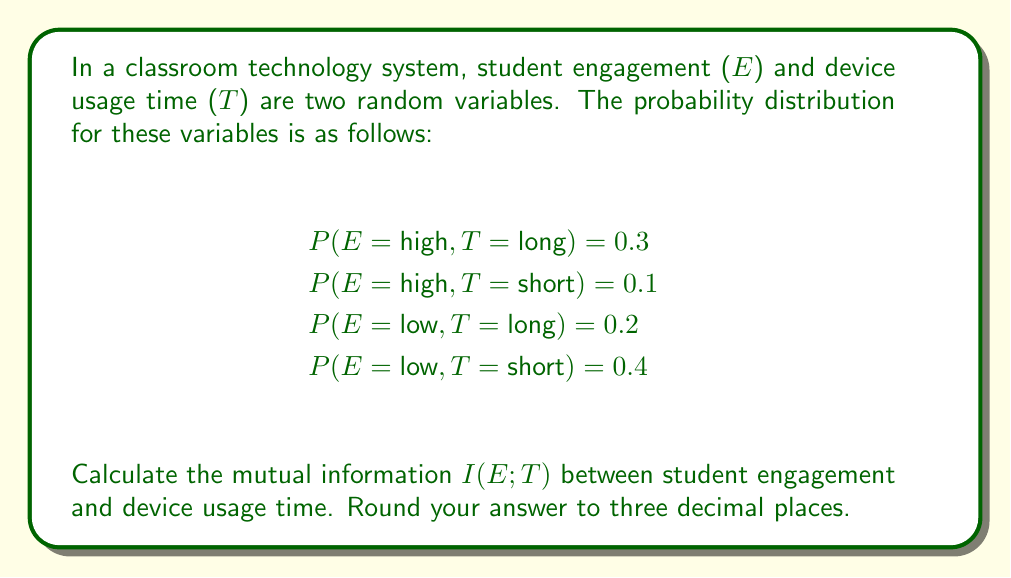Solve this math problem. To calculate the mutual information I(E;T), we'll follow these steps:

1. Calculate marginal probabilities:
   P(E = high) = 0.3 + 0.1 = 0.4
   P(E = low) = 0.2 + 0.4 = 0.6
   P(T = long) = 0.3 + 0.2 = 0.5
   P(T = short) = 0.1 + 0.4 = 0.5

2. Use the formula for mutual information:
   $$I(E;T) = \sum_{e \in E} \sum_{t \in T} P(e,t) \log_2 \frac{P(e,t)}{P(e)P(t)}$$

3. Calculate each term:
   $$0.3 \log_2 \frac{0.3}{0.4 \cdot 0.5} + 0.1 \log_2 \frac{0.1}{0.4 \cdot 0.5} + 0.2 \log_2 \frac{0.2}{0.6 \cdot 0.5} + 0.4 \log_2 \frac{0.4}{0.6 \cdot 0.5}$$

4. Simplify:
   $$0.3 \log_2 1.5 + 0.1 \log_2 0.5 + 0.2 \log_2 \frac{2}{3} + 0.4 \log_2 \frac{4}{3}$$

5. Calculate:
   $$0.3 \cdot 0.5850 + 0.1 \cdot (-1) + 0.2 \cdot (-0.5850) + 0.4 \cdot 0.4150$$

6. Sum up:
   $$0.1755 - 0.1 - 0.1170 + 0.1660 = 0.1245$$

Therefore, the mutual information I(E;T) ≈ 0.125 bits.
Answer: 0.125 bits 